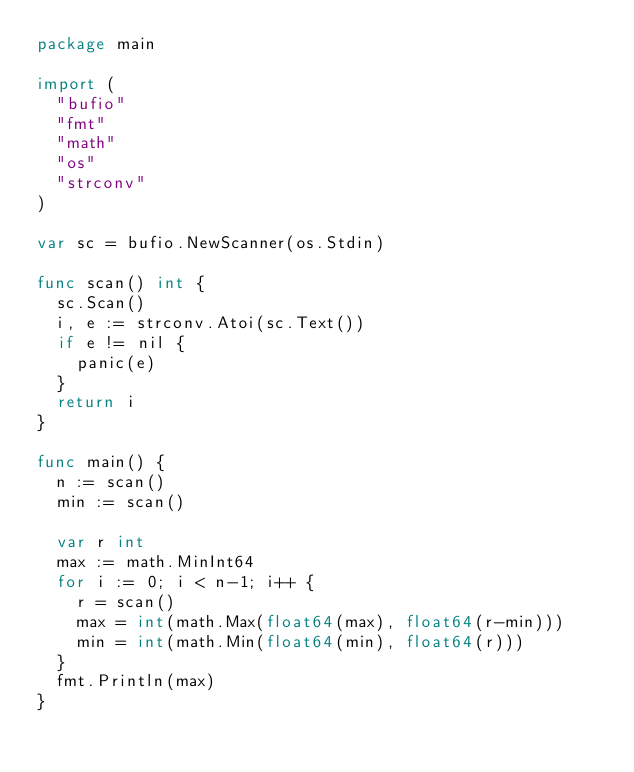<code> <loc_0><loc_0><loc_500><loc_500><_Go_>package main

import (
	"bufio"
	"fmt"
	"math"
	"os"
	"strconv"
)

var sc = bufio.NewScanner(os.Stdin)

func scan() int {
	sc.Scan()
	i, e := strconv.Atoi(sc.Text())
	if e != nil {
		panic(e)
	}
	return i
}

func main() {
	n := scan()
	min := scan()

	var r int
	max := math.MinInt64
	for i := 0; i < n-1; i++ {
		r = scan()
		max = int(math.Max(float64(max), float64(r-min)))
		min = int(math.Min(float64(min), float64(r)))
	}
	fmt.Println(max)
}
</code> 